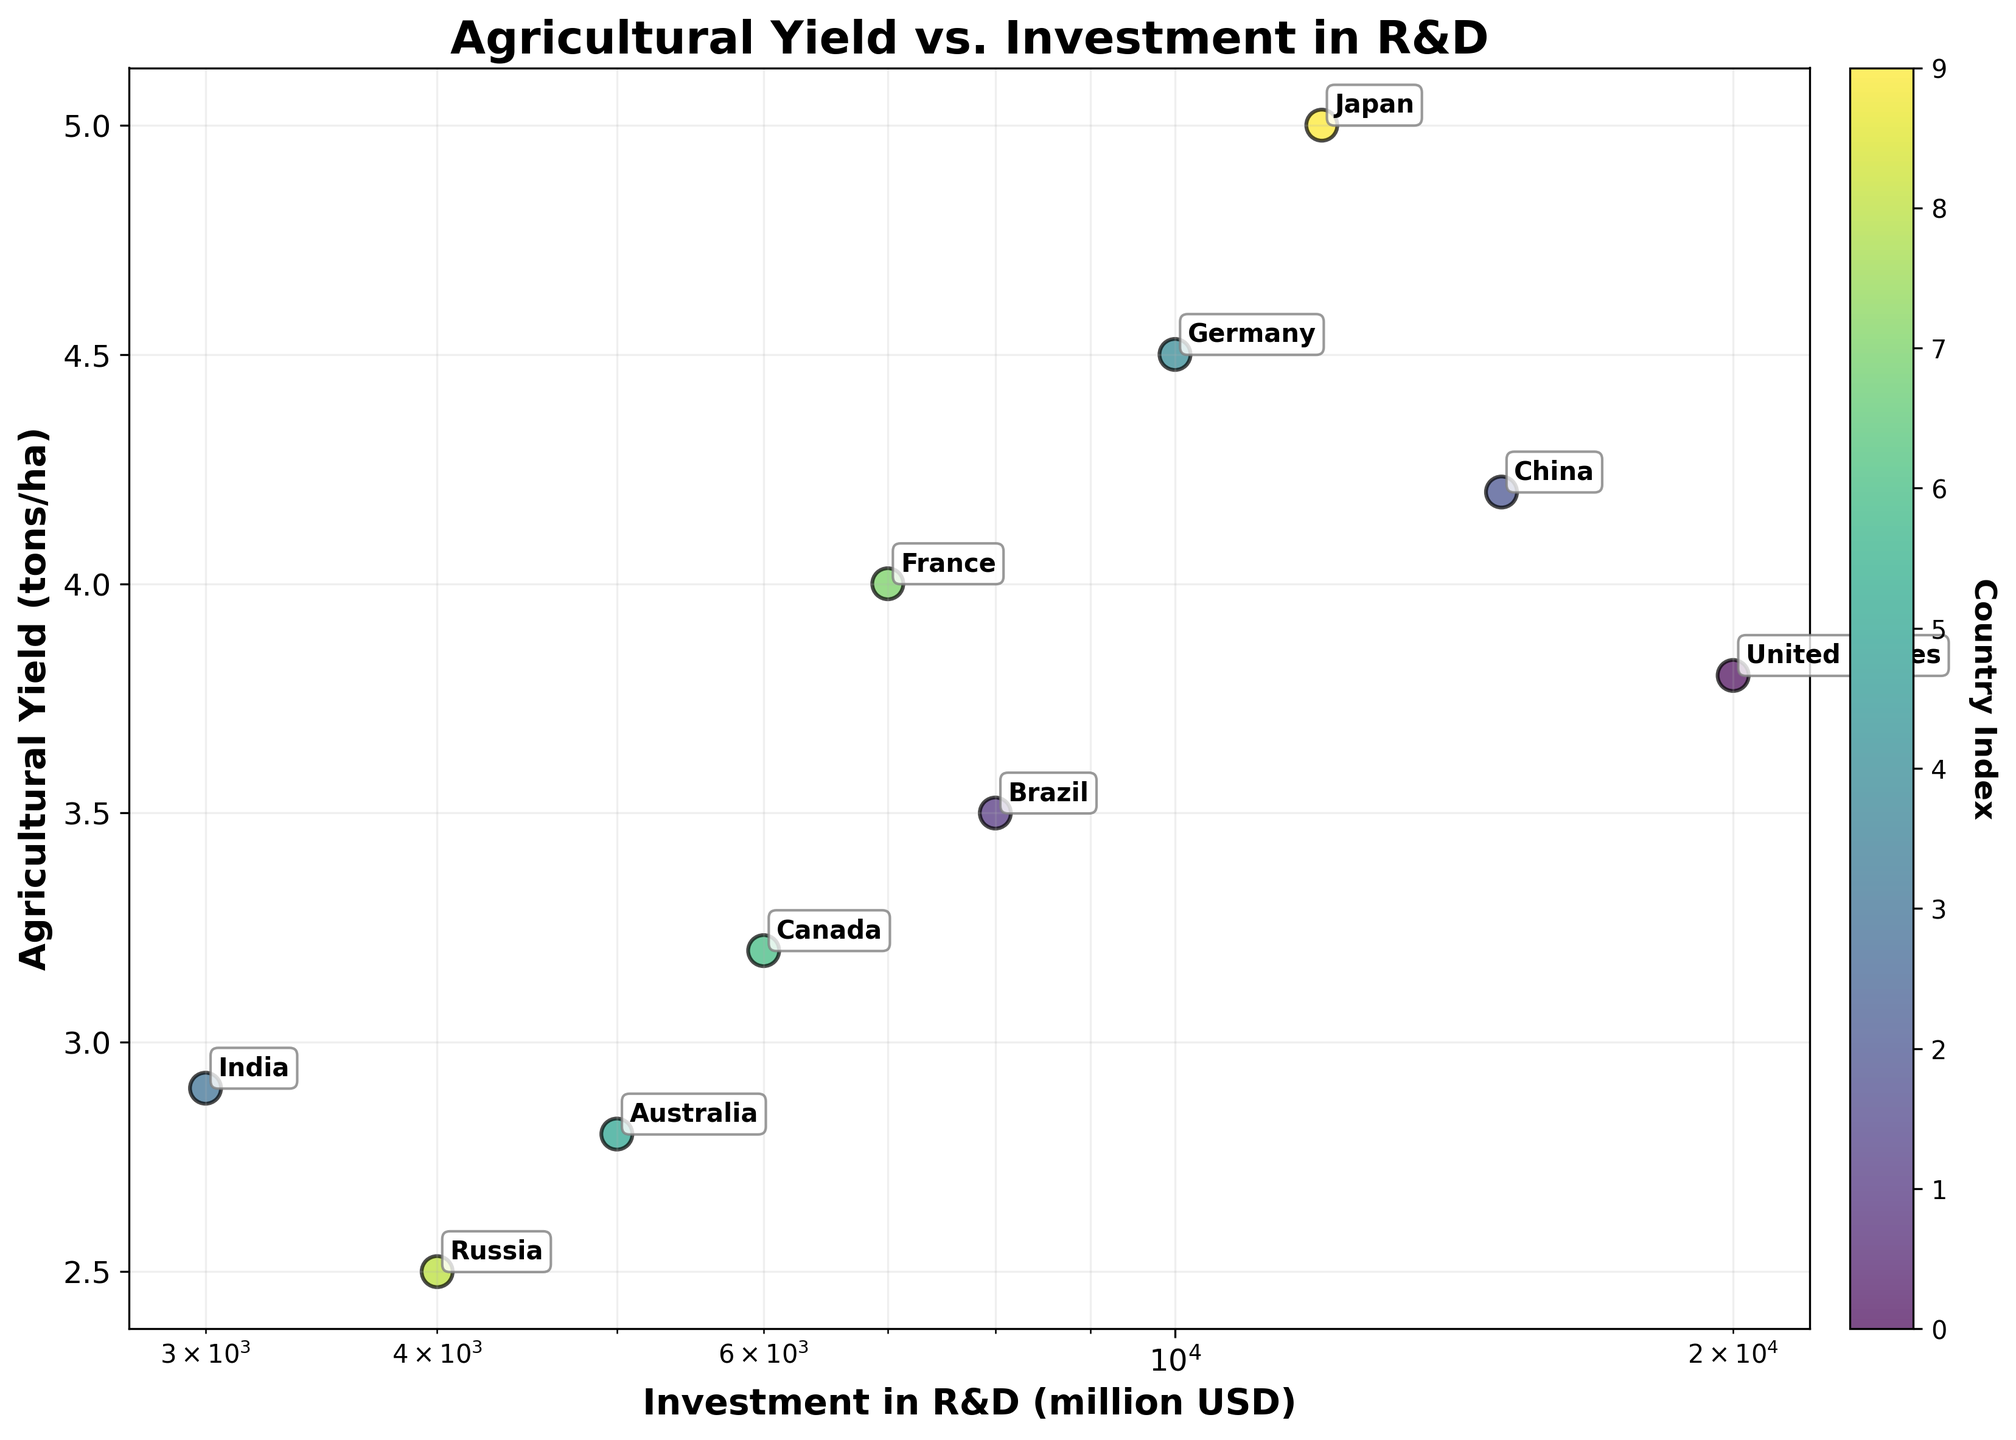What does the title of the figure say? The title of the figure can be found at the top of the plot in a bold font. It should provide a summary or topic for the plot depicted.
Answer: Agricultural Yield vs. Investment in R&D What axis is plotted on a log scale, and what does it represent? The axis plotted on a log scale is indicated by the unevenly spaced tick marks. It represents the investment amount in R&D as shown on the x-axis.
Answer: x-axis (Investment in R&D) Which country has the highest agricultural yield? Locate the point highest on the y-axis, then refer to the annotation next to it to identify the country.
Answer: Japan How many countries are represented in the figure? Count the number of distinct annotations or data points on the scatter plot. Each point represents a different country.
Answer: 10 Which countries have an agricultural yield less than 3 tons/ha and what are their corresponding investments in R&D? Identify points below the 3 tons/ha mark on the y-axis, then refer to the annotations for those points. Also, check the x-axis values for corresponding investment amounts.
Answer: India (3000 million USD), Russia (4000 million USD), Australia (5000 million USD) Compare the investment in R&D for the United States and Germany. Which country invests more? Look for the annotations for the United States and Germany and compare their positions on the x-axis. The country further to the right invests more.
Answer: United States What is the range of agricultural yields displayed in this scatter plot? Identify the lowest and highest points on the y-axis to determine the range.
Answer: 2.5 to 5.0 tons/ha How does Brazil's agricultural yield compare to China's? Locate the data points for Brazil and China, and compare their positions on the y-axis. The higher point indicates a higher yield.
Answer: China has a higher yield Is there a clear trend or correlation between investment in R&D and agricultural yield? Observe the general direction and clustering of data points in the scatter plot to determine if there's a discernible trend.
Answer: No clear trend 